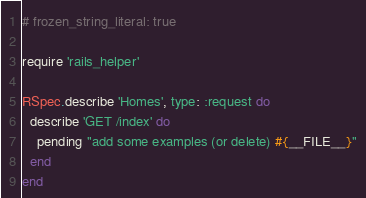<code> <loc_0><loc_0><loc_500><loc_500><_Ruby_># frozen_string_literal: true

require 'rails_helper'

RSpec.describe 'Homes', type: :request do
  describe 'GET /index' do
    pending "add some examples (or delete) #{__FILE__}"
  end
end
</code> 